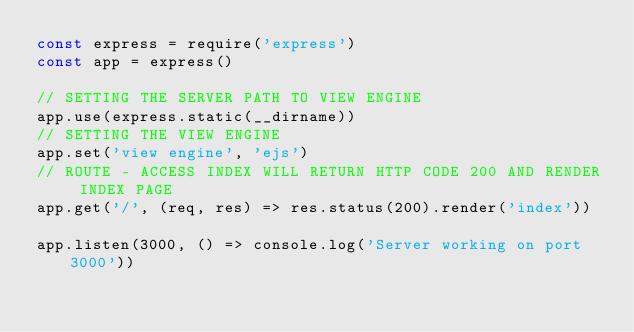Convert code to text. <code><loc_0><loc_0><loc_500><loc_500><_JavaScript_>const express = require('express')
const app = express()

// SETTING THE SERVER PATH TO VIEW ENGINE  
app.use(express.static(__dirname))
// SETTING THE VIEW ENGINE
app.set('view engine', 'ejs')
// ROUTE - ACCESS INDEX WILL RETURN HTTP CODE 200 AND RENDER INDEX PAGE
app.get('/', (req, res) => res.status(200).render('index'))

app.listen(3000, () => console.log('Server working on port 3000'))</code> 